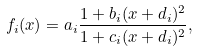Convert formula to latex. <formula><loc_0><loc_0><loc_500><loc_500>f _ { i } ( x ) = a _ { i } \frac { 1 + b _ { i } ( x + d _ { i } ) ^ { 2 } } { 1 + c _ { i } ( x + d _ { i } ) ^ { 2 } } ,</formula> 